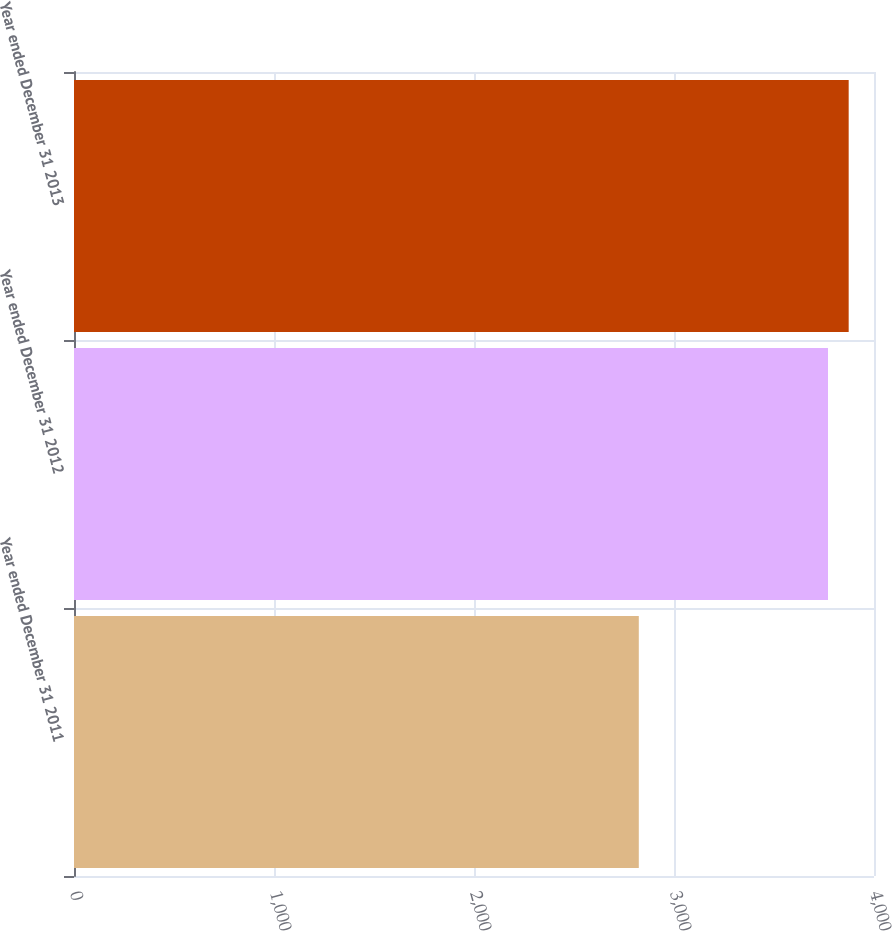Convert chart. <chart><loc_0><loc_0><loc_500><loc_500><bar_chart><fcel>Year ended December 31 2011<fcel>Year ended December 31 2012<fcel>Year ended December 31 2013<nl><fcel>2824<fcel>3770<fcel>3873.4<nl></chart> 